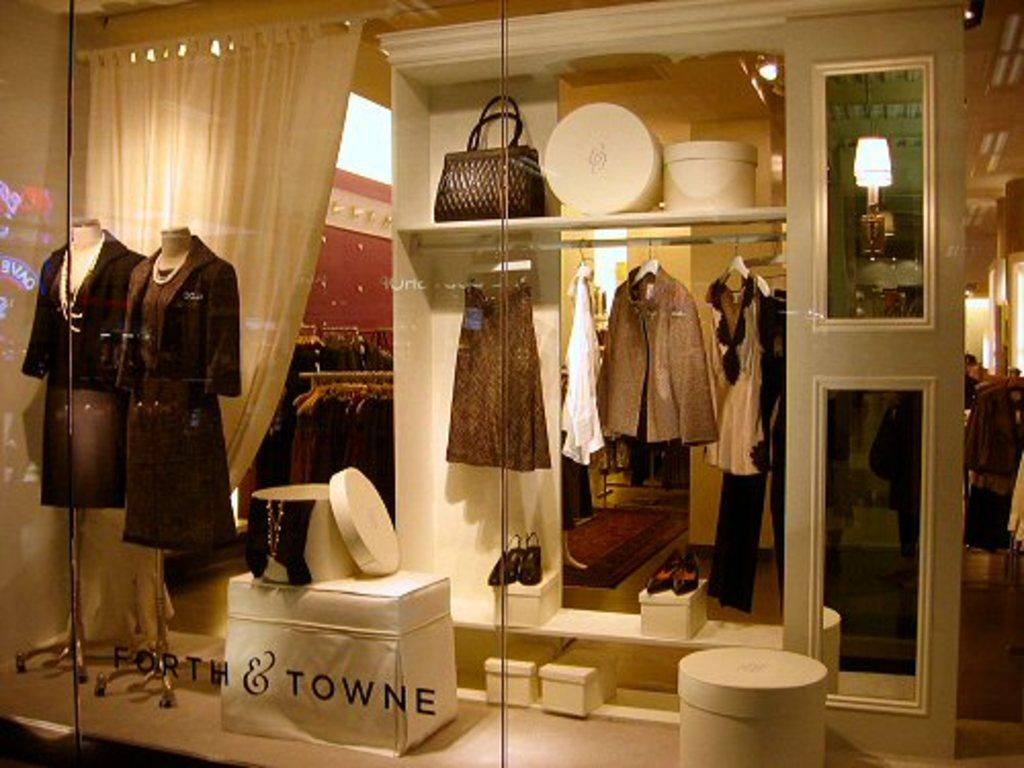<image>
Render a clear and concise summary of the photo. A view inside of a store with Forth & Towne etched on the window 